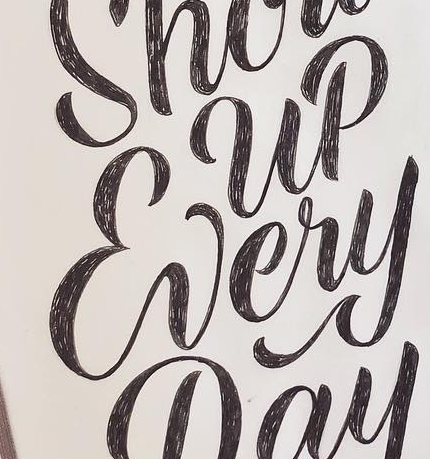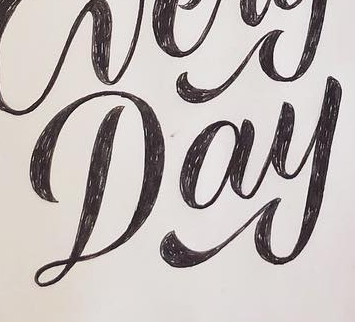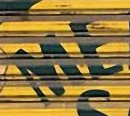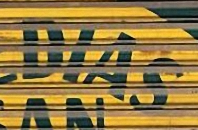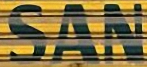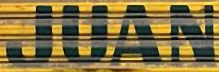What words can you see in these images in sequence, separated by a semicolon? Every; Day; ME; DIAS; SAN; JUAN 